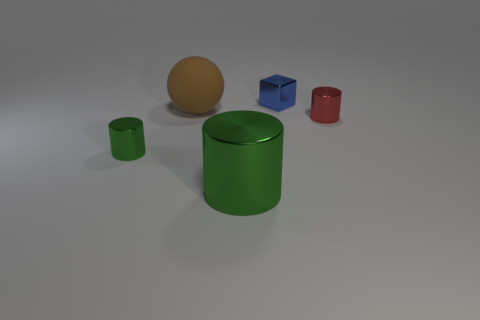Are there more big cylinders to the left of the tiny red metal cylinder than red metal things behind the brown matte sphere? No, there isn't a larger number of big cylinders to the left of the small red cylinder; in fact, there's just one small green cylinder in that position, and there are no red metal objects behind the brown sphere. 